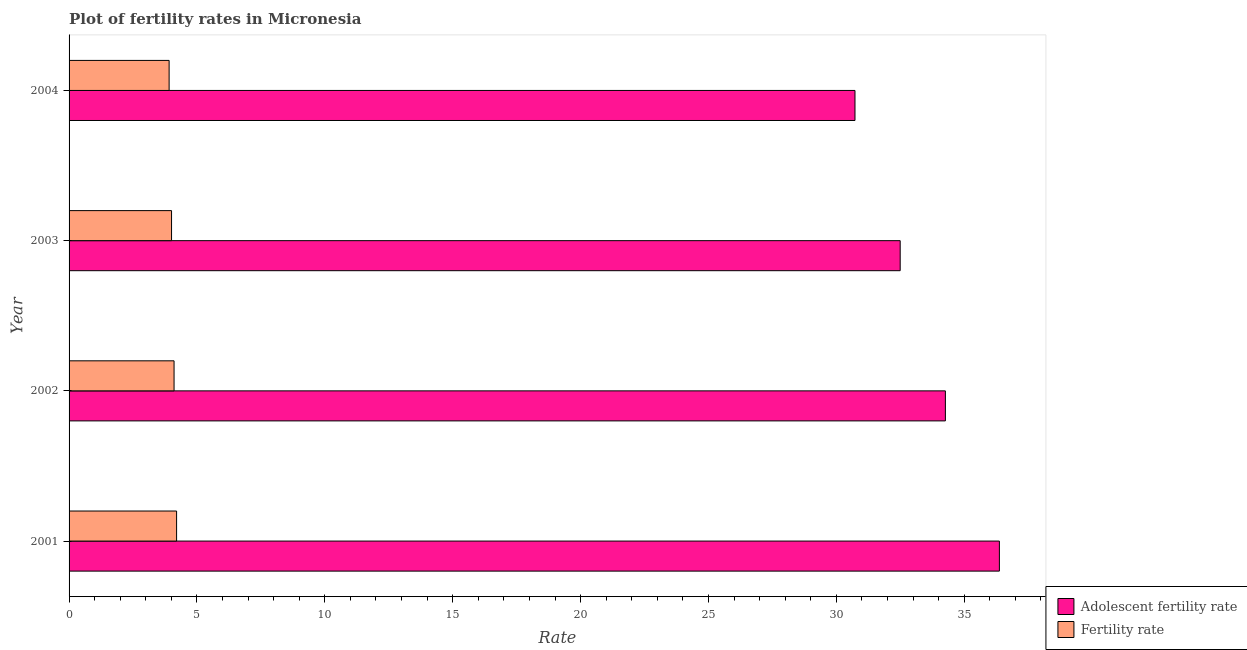What is the label of the 2nd group of bars from the top?
Your response must be concise. 2003. In how many cases, is the number of bars for a given year not equal to the number of legend labels?
Make the answer very short. 0. What is the fertility rate in 2003?
Your answer should be compact. 4.01. Across all years, what is the maximum adolescent fertility rate?
Your answer should be very brief. 36.37. Across all years, what is the minimum adolescent fertility rate?
Your answer should be compact. 30.73. In which year was the adolescent fertility rate maximum?
Your answer should be very brief. 2001. In which year was the fertility rate minimum?
Provide a short and direct response. 2004. What is the total adolescent fertility rate in the graph?
Ensure brevity in your answer.  133.86. What is the difference between the adolescent fertility rate in 2002 and that in 2004?
Provide a short and direct response. 3.54. What is the difference between the adolescent fertility rate in 2002 and the fertility rate in 2004?
Provide a succinct answer. 30.35. What is the average fertility rate per year?
Ensure brevity in your answer.  4.06. In the year 2003, what is the difference between the fertility rate and adolescent fertility rate?
Your answer should be compact. -28.49. In how many years, is the adolescent fertility rate greater than 10 ?
Keep it short and to the point. 4. What is the ratio of the fertility rate in 2001 to that in 2002?
Provide a succinct answer. 1.02. Is the adolescent fertility rate in 2001 less than that in 2004?
Your answer should be very brief. No. What is the difference between the highest and the second highest fertility rate?
Give a very brief answer. 0.1. What is the difference between the highest and the lowest adolescent fertility rate?
Your answer should be compact. 5.65. In how many years, is the fertility rate greater than the average fertility rate taken over all years?
Your answer should be compact. 2. What does the 2nd bar from the top in 2003 represents?
Keep it short and to the point. Adolescent fertility rate. What does the 2nd bar from the bottom in 2003 represents?
Your response must be concise. Fertility rate. How many years are there in the graph?
Provide a succinct answer. 4. Does the graph contain any zero values?
Your answer should be very brief. No. Does the graph contain grids?
Provide a short and direct response. No. Where does the legend appear in the graph?
Keep it short and to the point. Bottom right. What is the title of the graph?
Ensure brevity in your answer.  Plot of fertility rates in Micronesia. What is the label or title of the X-axis?
Make the answer very short. Rate. What is the label or title of the Y-axis?
Provide a succinct answer. Year. What is the Rate in Adolescent fertility rate in 2001?
Provide a succinct answer. 36.37. What is the Rate in Fertility rate in 2001?
Provide a short and direct response. 4.2. What is the Rate in Adolescent fertility rate in 2002?
Your response must be concise. 34.26. What is the Rate in Fertility rate in 2002?
Offer a very short reply. 4.11. What is the Rate in Adolescent fertility rate in 2003?
Provide a succinct answer. 32.5. What is the Rate of Fertility rate in 2003?
Provide a succinct answer. 4.01. What is the Rate of Adolescent fertility rate in 2004?
Give a very brief answer. 30.73. What is the Rate in Fertility rate in 2004?
Offer a very short reply. 3.91. Across all years, what is the maximum Rate of Adolescent fertility rate?
Provide a short and direct response. 36.37. Across all years, what is the maximum Rate in Fertility rate?
Ensure brevity in your answer.  4.2. Across all years, what is the minimum Rate in Adolescent fertility rate?
Give a very brief answer. 30.73. Across all years, what is the minimum Rate of Fertility rate?
Your answer should be very brief. 3.91. What is the total Rate of Adolescent fertility rate in the graph?
Ensure brevity in your answer.  133.86. What is the total Rate of Fertility rate in the graph?
Your answer should be very brief. 16.23. What is the difference between the Rate of Adolescent fertility rate in 2001 and that in 2002?
Your answer should be compact. 2.11. What is the difference between the Rate in Fertility rate in 2001 and that in 2002?
Keep it short and to the point. 0.1. What is the difference between the Rate in Adolescent fertility rate in 2001 and that in 2003?
Ensure brevity in your answer.  3.88. What is the difference between the Rate of Fertility rate in 2001 and that in 2003?
Provide a short and direct response. 0.2. What is the difference between the Rate in Adolescent fertility rate in 2001 and that in 2004?
Your response must be concise. 5.65. What is the difference between the Rate of Fertility rate in 2001 and that in 2004?
Give a very brief answer. 0.29. What is the difference between the Rate of Adolescent fertility rate in 2002 and that in 2003?
Your answer should be compact. 1.77. What is the difference between the Rate of Fertility rate in 2002 and that in 2003?
Provide a succinct answer. 0.1. What is the difference between the Rate in Adolescent fertility rate in 2002 and that in 2004?
Offer a very short reply. 3.53. What is the difference between the Rate in Fertility rate in 2002 and that in 2004?
Provide a succinct answer. 0.19. What is the difference between the Rate in Adolescent fertility rate in 2003 and that in 2004?
Provide a succinct answer. 1.77. What is the difference between the Rate of Fertility rate in 2003 and that in 2004?
Ensure brevity in your answer.  0.1. What is the difference between the Rate in Adolescent fertility rate in 2001 and the Rate in Fertility rate in 2002?
Your answer should be compact. 32.27. What is the difference between the Rate of Adolescent fertility rate in 2001 and the Rate of Fertility rate in 2003?
Provide a succinct answer. 32.37. What is the difference between the Rate in Adolescent fertility rate in 2001 and the Rate in Fertility rate in 2004?
Your answer should be very brief. 32.46. What is the difference between the Rate of Adolescent fertility rate in 2002 and the Rate of Fertility rate in 2003?
Your answer should be compact. 30.26. What is the difference between the Rate in Adolescent fertility rate in 2002 and the Rate in Fertility rate in 2004?
Provide a succinct answer. 30.35. What is the difference between the Rate in Adolescent fertility rate in 2003 and the Rate in Fertility rate in 2004?
Offer a terse response. 28.58. What is the average Rate of Adolescent fertility rate per year?
Provide a short and direct response. 33.47. What is the average Rate of Fertility rate per year?
Keep it short and to the point. 4.06. In the year 2001, what is the difference between the Rate in Adolescent fertility rate and Rate in Fertility rate?
Provide a succinct answer. 32.17. In the year 2002, what is the difference between the Rate in Adolescent fertility rate and Rate in Fertility rate?
Your answer should be very brief. 30.16. In the year 2003, what is the difference between the Rate of Adolescent fertility rate and Rate of Fertility rate?
Your answer should be compact. 28.49. In the year 2004, what is the difference between the Rate of Adolescent fertility rate and Rate of Fertility rate?
Your response must be concise. 26.82. What is the ratio of the Rate in Adolescent fertility rate in 2001 to that in 2002?
Keep it short and to the point. 1.06. What is the ratio of the Rate in Fertility rate in 2001 to that in 2002?
Make the answer very short. 1.02. What is the ratio of the Rate of Adolescent fertility rate in 2001 to that in 2003?
Make the answer very short. 1.12. What is the ratio of the Rate in Fertility rate in 2001 to that in 2003?
Offer a very short reply. 1.05. What is the ratio of the Rate in Adolescent fertility rate in 2001 to that in 2004?
Provide a succinct answer. 1.18. What is the ratio of the Rate in Fertility rate in 2001 to that in 2004?
Make the answer very short. 1.07. What is the ratio of the Rate of Adolescent fertility rate in 2002 to that in 2003?
Offer a very short reply. 1.05. What is the ratio of the Rate of Fertility rate in 2002 to that in 2003?
Offer a terse response. 1.02. What is the ratio of the Rate of Adolescent fertility rate in 2002 to that in 2004?
Keep it short and to the point. 1.11. What is the ratio of the Rate of Fertility rate in 2002 to that in 2004?
Offer a terse response. 1.05. What is the ratio of the Rate of Adolescent fertility rate in 2003 to that in 2004?
Your response must be concise. 1.06. What is the ratio of the Rate of Fertility rate in 2003 to that in 2004?
Offer a very short reply. 1.02. What is the difference between the highest and the second highest Rate in Adolescent fertility rate?
Your response must be concise. 2.11. What is the difference between the highest and the second highest Rate of Fertility rate?
Your answer should be very brief. 0.1. What is the difference between the highest and the lowest Rate of Adolescent fertility rate?
Keep it short and to the point. 5.65. What is the difference between the highest and the lowest Rate of Fertility rate?
Offer a terse response. 0.29. 